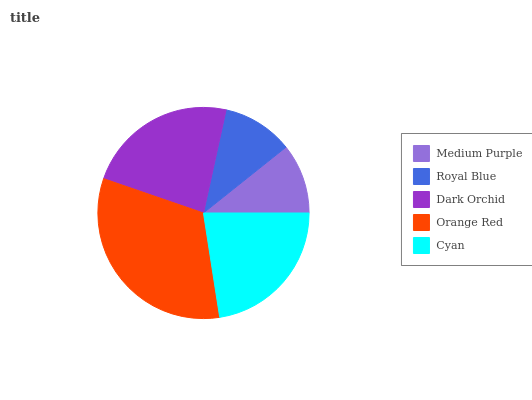Is Medium Purple the minimum?
Answer yes or no. Yes. Is Orange Red the maximum?
Answer yes or no. Yes. Is Royal Blue the minimum?
Answer yes or no. No. Is Royal Blue the maximum?
Answer yes or no. No. Is Royal Blue greater than Medium Purple?
Answer yes or no. Yes. Is Medium Purple less than Royal Blue?
Answer yes or no. Yes. Is Medium Purple greater than Royal Blue?
Answer yes or no. No. Is Royal Blue less than Medium Purple?
Answer yes or no. No. Is Cyan the high median?
Answer yes or no. Yes. Is Cyan the low median?
Answer yes or no. Yes. Is Dark Orchid the high median?
Answer yes or no. No. Is Royal Blue the low median?
Answer yes or no. No. 